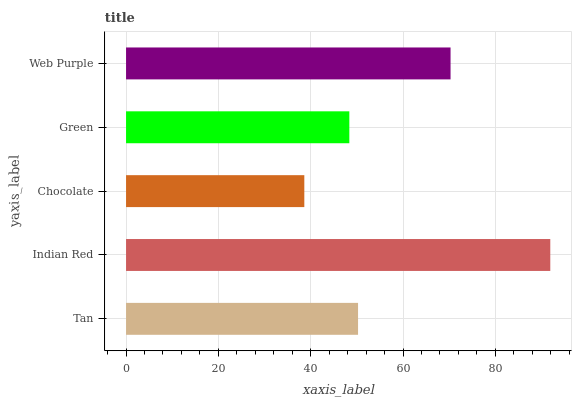Is Chocolate the minimum?
Answer yes or no. Yes. Is Indian Red the maximum?
Answer yes or no. Yes. Is Indian Red the minimum?
Answer yes or no. No. Is Chocolate the maximum?
Answer yes or no. No. Is Indian Red greater than Chocolate?
Answer yes or no. Yes. Is Chocolate less than Indian Red?
Answer yes or no. Yes. Is Chocolate greater than Indian Red?
Answer yes or no. No. Is Indian Red less than Chocolate?
Answer yes or no. No. Is Tan the high median?
Answer yes or no. Yes. Is Tan the low median?
Answer yes or no. Yes. Is Web Purple the high median?
Answer yes or no. No. Is Chocolate the low median?
Answer yes or no. No. 